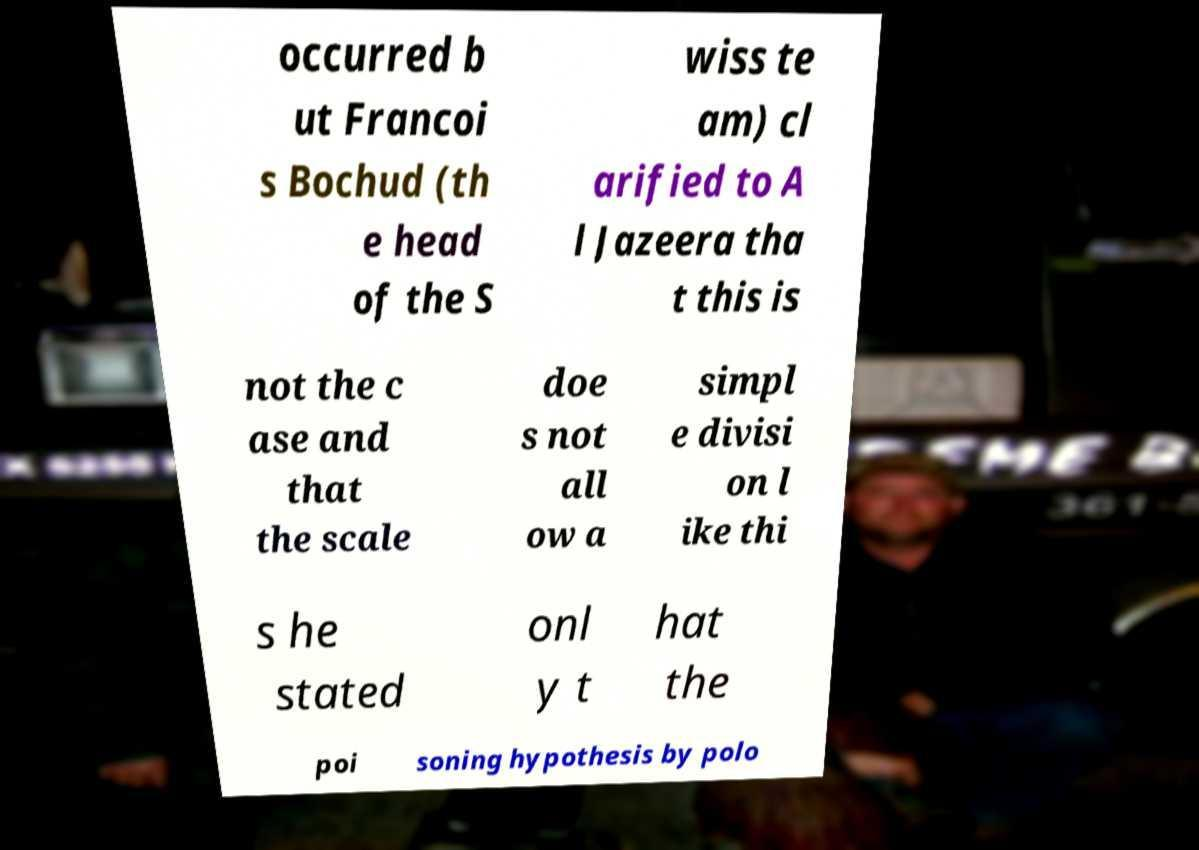For documentation purposes, I need the text within this image transcribed. Could you provide that? occurred b ut Francoi s Bochud (th e head of the S wiss te am) cl arified to A l Jazeera tha t this is not the c ase and that the scale doe s not all ow a simpl e divisi on l ike thi s he stated onl y t hat the poi soning hypothesis by polo 